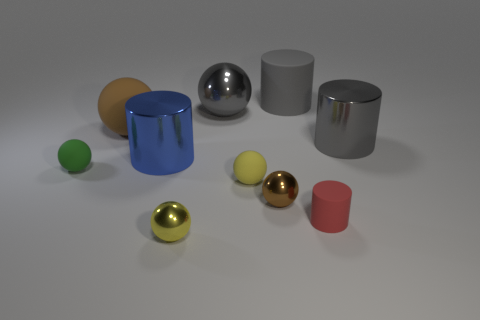There is a cylinder that is the same size as the green thing; what is its color?
Your response must be concise. Red. Is there anything else that has the same shape as the small red object?
Offer a very short reply. Yes. What is the color of the large rubber object that is the same shape as the tiny brown shiny object?
Offer a terse response. Brown. How many things are yellow rubber things or metal objects that are in front of the small green sphere?
Give a very brief answer. 3. Is the number of green rubber balls that are on the right side of the red rubber cylinder less than the number of metallic balls?
Make the answer very short. Yes. What size is the rubber cylinder that is behind the metal cylinder that is behind the metallic cylinder that is on the left side of the gray matte cylinder?
Offer a very short reply. Large. There is a thing that is on the right side of the tiny yellow rubber thing and in front of the tiny brown ball; what color is it?
Ensure brevity in your answer.  Red. How many big green matte things are there?
Ensure brevity in your answer.  0. Are there any other things that have the same size as the blue cylinder?
Provide a short and direct response. Yes. Do the blue cylinder and the red object have the same material?
Provide a succinct answer. No. 